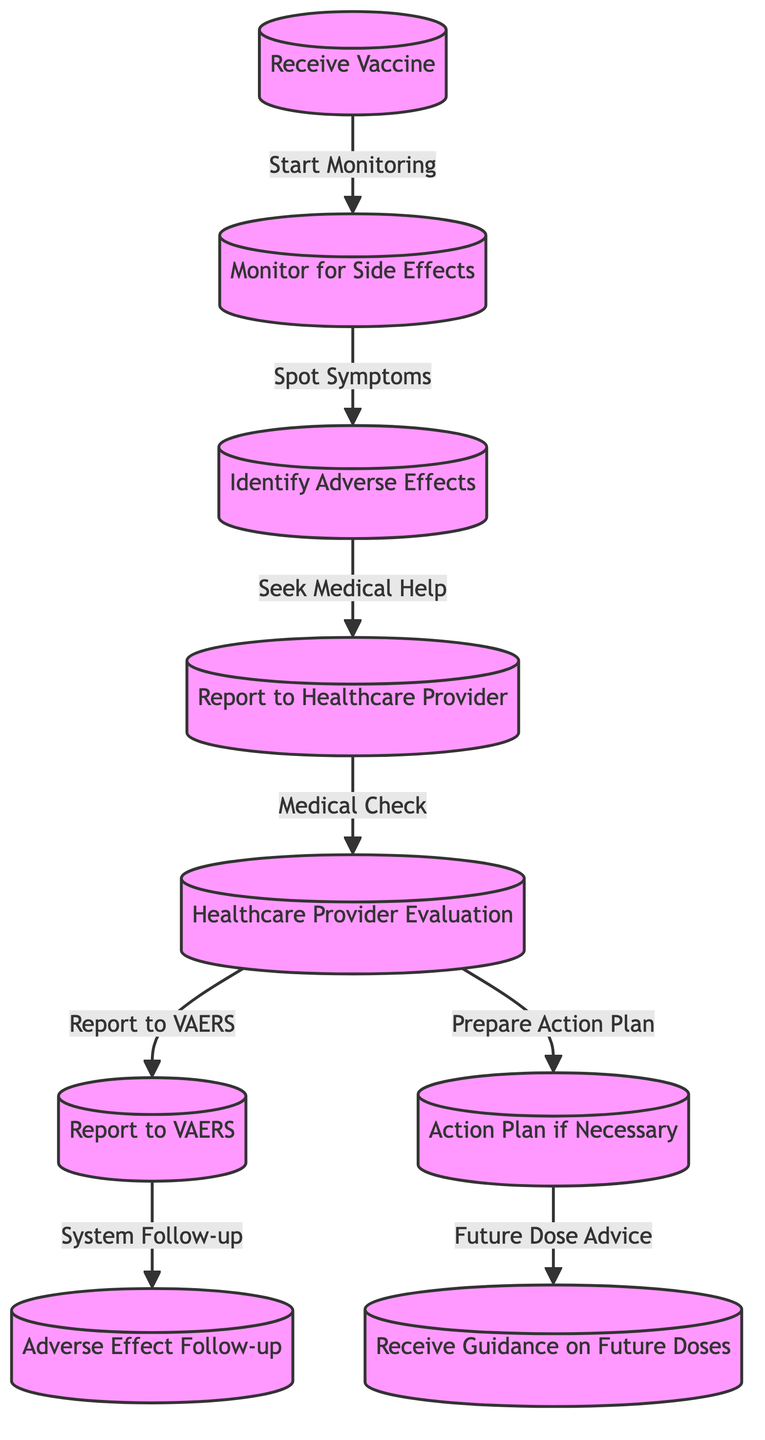What's the starting point of the monitoring process? The monitoring process begins after the action of "Receive Vaccine," which is the first node in the diagram.
Answer: Receive Vaccine What is the last step in the reporting process? The last step shown in the diagram is "Receive Guidance on Future Doses," which is the final node that follows the action plan if necessary.
Answer: Receive Guidance on Future Doses How many nodes are present in the diagram? The diagram contains a total of 9 nodes, each representing a step in the process.
Answer: 9 What action follows after "Identify Adverse Effects"? After identifying adverse effects, the next action is to "Report to Healthcare Provider," which is directly linked as the subsequent step in the flow.
Answer: Report to Healthcare Provider Which node involves a medical evaluation? The node that involves a medical evaluation is "Healthcare Provider Evaluation," which follows the reporting of adverse effects to the healthcare provider.
Answer: Healthcare Provider Evaluation What is the relationship between "Report to Healthcare Provider" and "Report to VAERS"? "Report to Healthcare Provider" is a preceding step that leads to the "Report to VAERS," indicating that the healthcare evaluation completes before reporting to the VAERS system.
Answer: Preceding step What happens during the "Adverse Effect Follow-up"? The "Adverse Effect Follow-up" involves a system follow-up after reporting to VAERS, aimed to monitor the long-term impact of the reported adverse effects.
Answer: System Follow-up What step comes immediately after the "Healthcare Provider Evaluation"? The step that comes immediately after "Healthcare Provider Evaluation" is "Report to VAERS," indicating that the evaluation leads to the reporting in the VAERS system.
Answer: Report to VAERS Which node provides guidance for future vaccine doses? The node that provides guidance for future vaccine doses is "Receive Guidance on Future Doses," showing the final outcome of the entire process based on previous steps.
Answer: Receive Guidance on Future Doses 